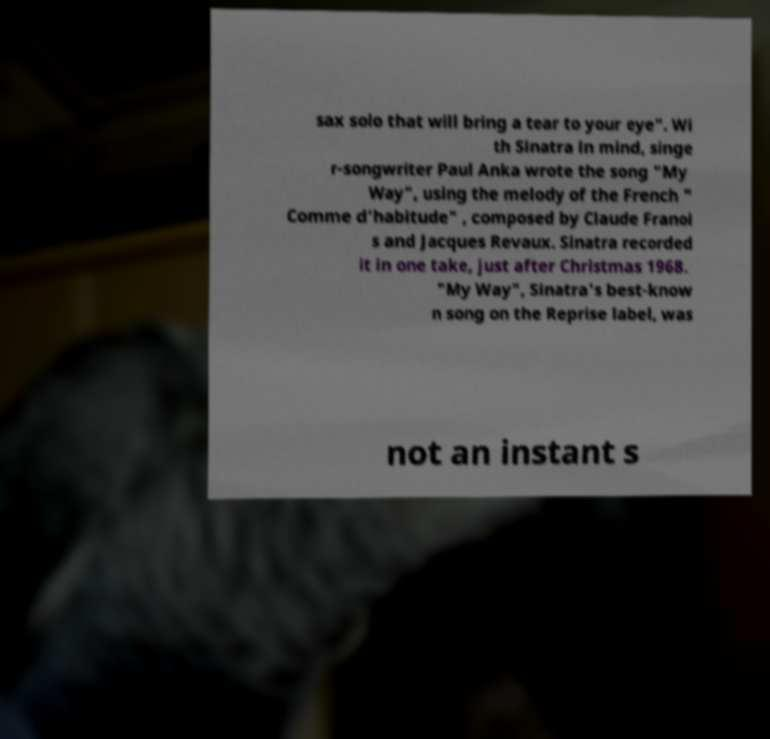For documentation purposes, I need the text within this image transcribed. Could you provide that? sax solo that will bring a tear to your eye". Wi th Sinatra in mind, singe r-songwriter Paul Anka wrote the song "My Way", using the melody of the French " Comme d'habitude" , composed by Claude Franoi s and Jacques Revaux. Sinatra recorded it in one take, just after Christmas 1968. "My Way", Sinatra's best-know n song on the Reprise label, was not an instant s 